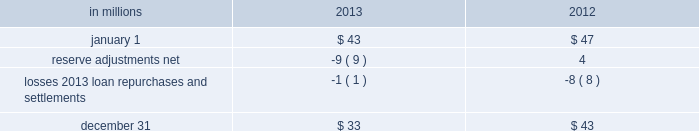Recourse and repurchase obligations as discussed in note 3 loan sale and servicing activities and variable interest entities , pnc has sold commercial mortgage , residential mortgage and home equity loans directly or indirectly through securitization and loan sale transactions in which we have continuing involvement .
One form of continuing involvement includes certain recourse and loan repurchase obligations associated with the transferred assets .
Commercial mortgage loan recourse obligations we originate , close and service certain multi-family commercial mortgage loans which are sold to fnma under fnma 2019s delegated underwriting and servicing ( dus ) program .
We participated in a similar program with the fhlmc .
Under these programs , we generally assume up to a one-third pari passu risk of loss on unpaid principal balances through a loss share arrangement .
At december 31 , 2013 and december 31 , 2012 , the unpaid principal balance outstanding of loans sold as a participant in these programs was $ 11.7 billion and $ 12.8 billion , respectively .
The potential maximum exposure under the loss share arrangements was $ 3.6 billion at december 31 , 2013 and $ 3.9 billion at december 31 , 2012 .
We maintain a reserve for estimated losses based upon our exposure .
The reserve for losses under these programs totaled $ 33 million and $ 43 million as of december 31 , 2013 and december 31 , 2012 , respectively , and is included in other liabilities on our consolidated balance sheet .
If payment is required under these programs , we would not have a contractual interest in the collateral underlying the mortgage loans on which losses occurred , although the value of the collateral is taken into account in determining our share of such losses .
Our exposure and activity associated with these recourse obligations are reported in the corporate & institutional banking segment .
Table 152 : analysis of commercial mortgage recourse obligations .
Residential mortgage loan and home equity repurchase obligations while residential mortgage loans are sold on a non-recourse basis , we assume certain loan repurchase obligations associated with mortgage loans we have sold to investors .
These loan repurchase obligations primarily relate to situations where pnc is alleged to have breached certain origination covenants and representations and warranties made to purchasers of the loans in the respective purchase and sale agreements .
For additional information on loan sales see note 3 loan sale and servicing activities and variable interest entities .
Our historical exposure and activity associated with agency securitization repurchase obligations has primarily been related to transactions with fnma and fhlmc , as indemnification and repurchase losses associated with fha and va-insured and uninsured loans pooled in gnma securitizations historically have been minimal .
Repurchase obligation activity associated with residential mortgages is reported in the residential mortgage banking segment .
In the fourth quarter of 2013 , pnc reached agreements with both fnma and fhlmc to resolve their repurchase claims with respect to loans sold between 2000 and 2008 .
Pnc paid a total of $ 191 million related to these settlements .
Pnc 2019s repurchase obligations also include certain brokered home equity loans/lines of credit that were sold to a limited number of private investors in the financial services industry by national city prior to our acquisition of national city .
Pnc is no longer engaged in the brokered home equity lending business , and our exposure under these loan repurchase obligations is limited to repurchases of loans sold in these transactions .
Repurchase activity associated with brokered home equity loans/lines of credit is reported in the non-strategic assets portfolio segment .
Indemnification and repurchase liabilities are initially recognized when loans are sold to investors and are subsequently evaluated by management .
Initial recognition and subsequent adjustments to the indemnification and repurchase liability for the sold residential mortgage portfolio are recognized in residential mortgage revenue on the consolidated income statement .
Since pnc is no longer engaged in the brokered home equity lending business , only subsequent adjustments are recognized to the home equity loans/lines indemnification and repurchase liability .
These adjustments are recognized in other noninterest income on the consolidated income statement .
214 the pnc financial services group , inc .
2013 form 10-k .
In millions for 2013 , what was the net change in commercial mortgage recourse obligations? 
Computations: (43 - 33)
Answer: 10.0. 